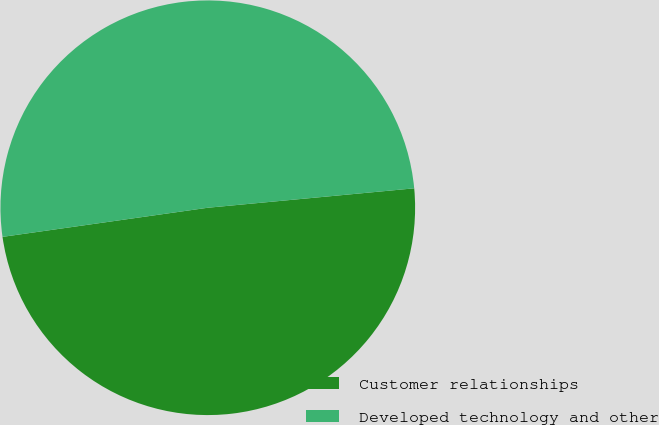Convert chart to OTSL. <chart><loc_0><loc_0><loc_500><loc_500><pie_chart><fcel>Customer relationships<fcel>Developed technology and other<nl><fcel>49.25%<fcel>50.75%<nl></chart> 